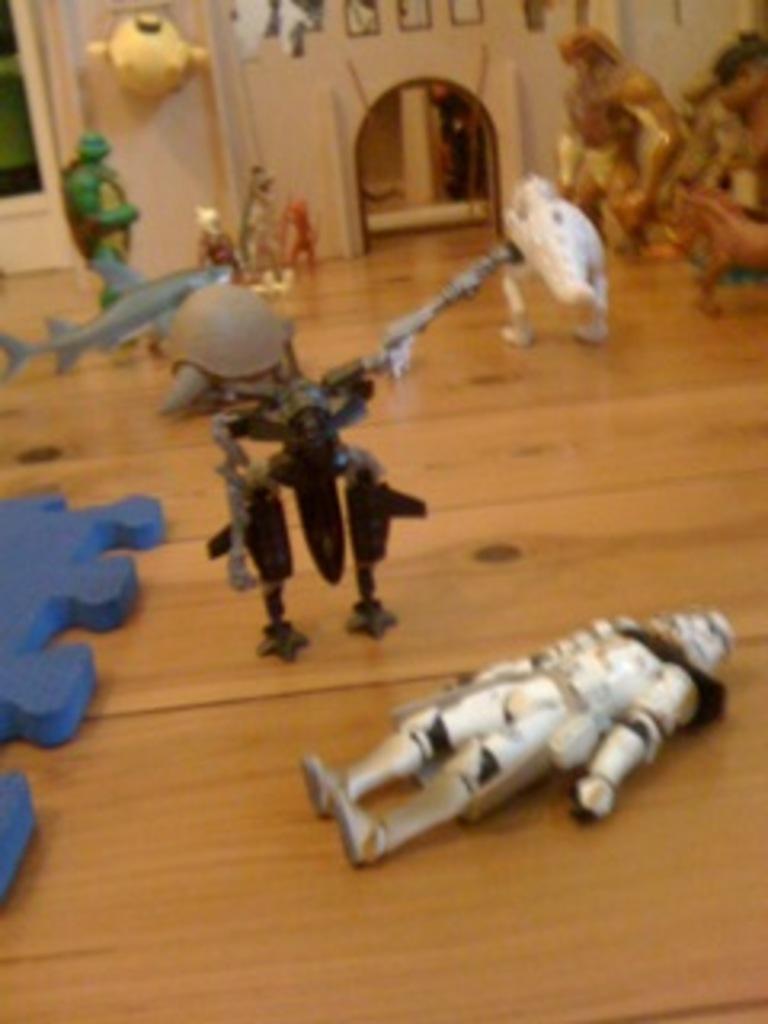In one or two sentences, can you explain what this image depicts? In this image, I can see toys on the floor and some objects. In the background, I can see a wall, door and I can see photo frames. This image taken, maybe in a hall. 